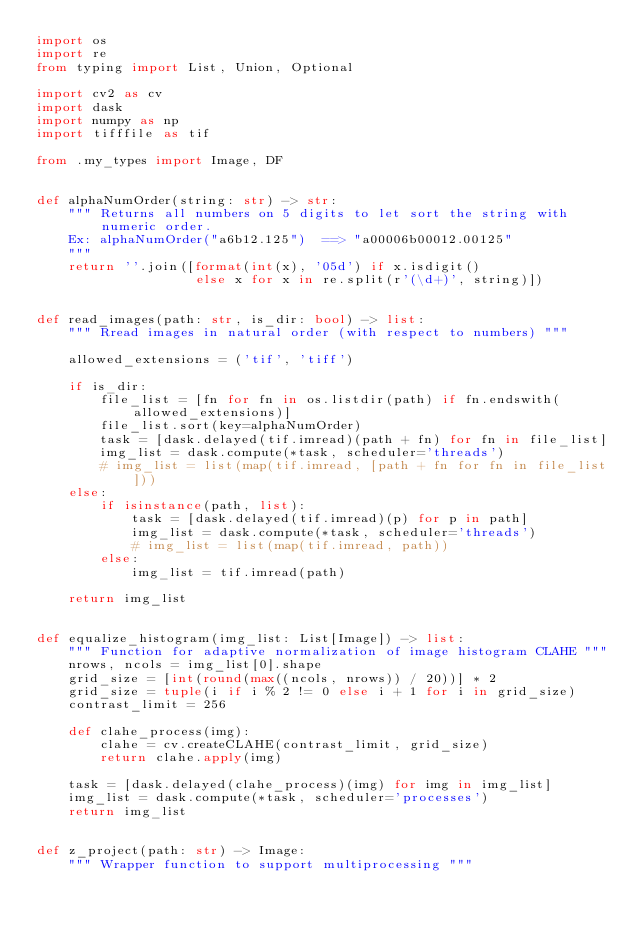<code> <loc_0><loc_0><loc_500><loc_500><_Python_>import os
import re
from typing import List, Union, Optional

import cv2 as cv
import dask
import numpy as np
import tifffile as tif

from .my_types import Image, DF


def alphaNumOrder(string: str) -> str:
    """ Returns all numbers on 5 digits to let sort the string with numeric order.
    Ex: alphaNumOrder("a6b12.125")  ==> "a00006b00012.00125"
    """
    return ''.join([format(int(x), '05d') if x.isdigit()
                    else x for x in re.split(r'(\d+)', string)])


def read_images(path: str, is_dir: bool) -> list:
    """ Rread images in natural order (with respect to numbers) """

    allowed_extensions = ('tif', 'tiff')

    if is_dir:
        file_list = [fn for fn in os.listdir(path) if fn.endswith(allowed_extensions)]
        file_list.sort(key=alphaNumOrder)
        task = [dask.delayed(tif.imread)(path + fn) for fn in file_list]
        img_list = dask.compute(*task, scheduler='threads')
        # img_list = list(map(tif.imread, [path + fn for fn in file_list]))
    else:
        if isinstance(path, list):
            task = [dask.delayed(tif.imread)(p) for p in path]
            img_list = dask.compute(*task, scheduler='threads')
            # img_list = list(map(tif.imread, path))
        else:
            img_list = tif.imread(path)

    return img_list


def equalize_histogram(img_list: List[Image]) -> list:
    """ Function for adaptive normalization of image histogram CLAHE """
    nrows, ncols = img_list[0].shape
    grid_size = [int(round(max((ncols, nrows)) / 20))] * 2
    grid_size = tuple(i if i % 2 != 0 else i + 1 for i in grid_size)
    contrast_limit = 256

    def clahe_process(img):
        clahe = cv.createCLAHE(contrast_limit, grid_size)
        return clahe.apply(img)

    task = [dask.delayed(clahe_process)(img) for img in img_list]
    img_list = dask.compute(*task, scheduler='processes')
    return img_list


def z_project(path: str) -> Image:
    """ Wrapper function to support multiprocessing """</code> 